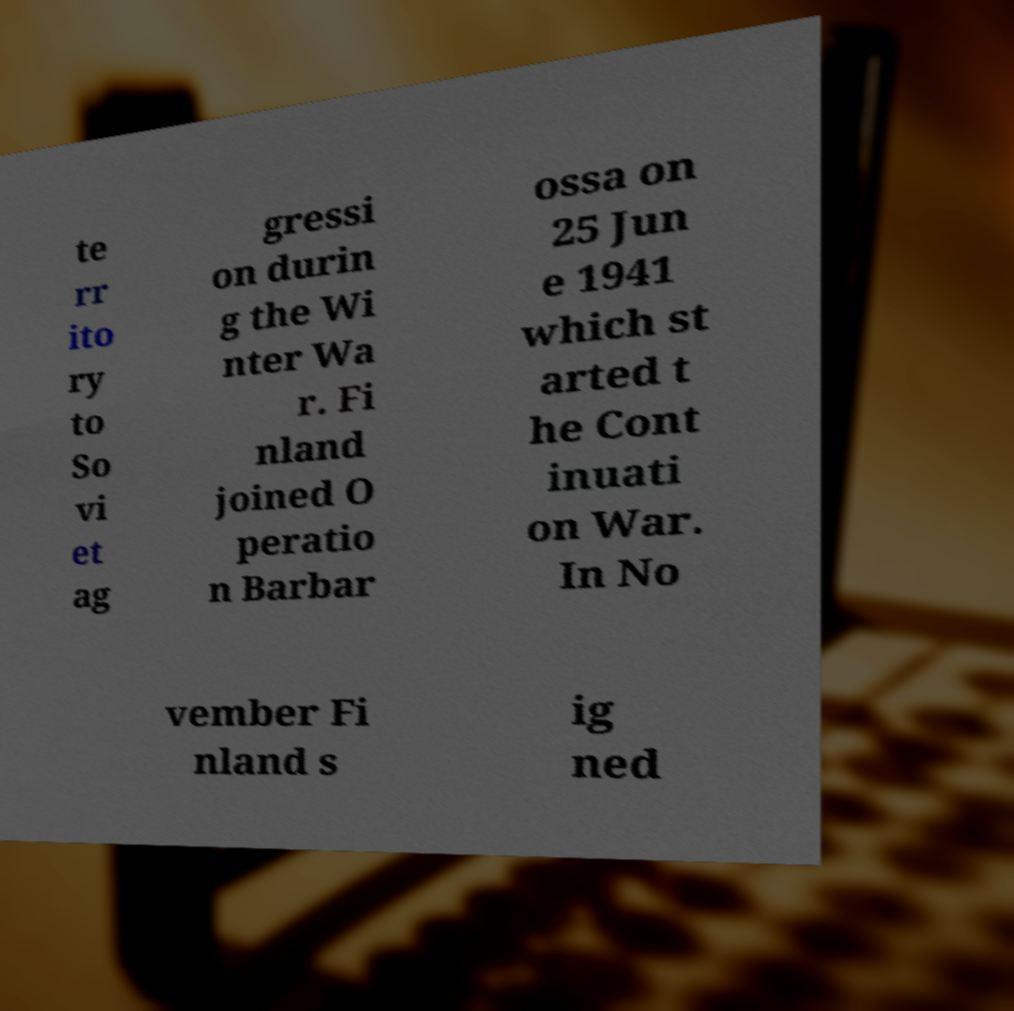Please identify and transcribe the text found in this image. te rr ito ry to So vi et ag gressi on durin g the Wi nter Wa r. Fi nland joined O peratio n Barbar ossa on 25 Jun e 1941 which st arted t he Cont inuati on War. In No vember Fi nland s ig ned 